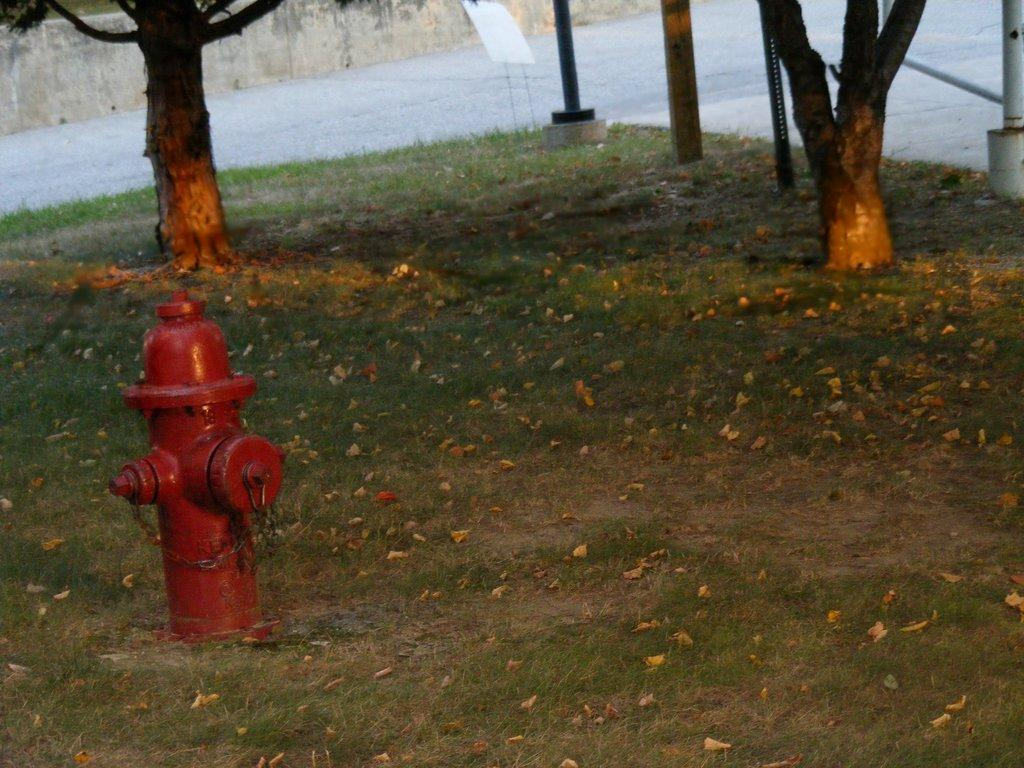What object can be seen in the image that is used for fire safety? There is a fire hydrant in the image. What type of natural feature is visible in the image? Tree trunks are visible in the image. What are the poles used for in the image? The purpose of the poles is not specified in the image, but they could be used for various purposes such as signage or lighting. What is the board used for in the image? The purpose of the board is not specified in the image, but it could be used for displaying information or as a surface for writing or drawing. What type of debris can be seen on the grass in the image? Dried leaves are on the grass in the image. What type of man-made feature is visible in the background of the image? There is a pathway in the background of the image. What type of apple is being used as a stick in the image? There is no apple or stick present in the image. 